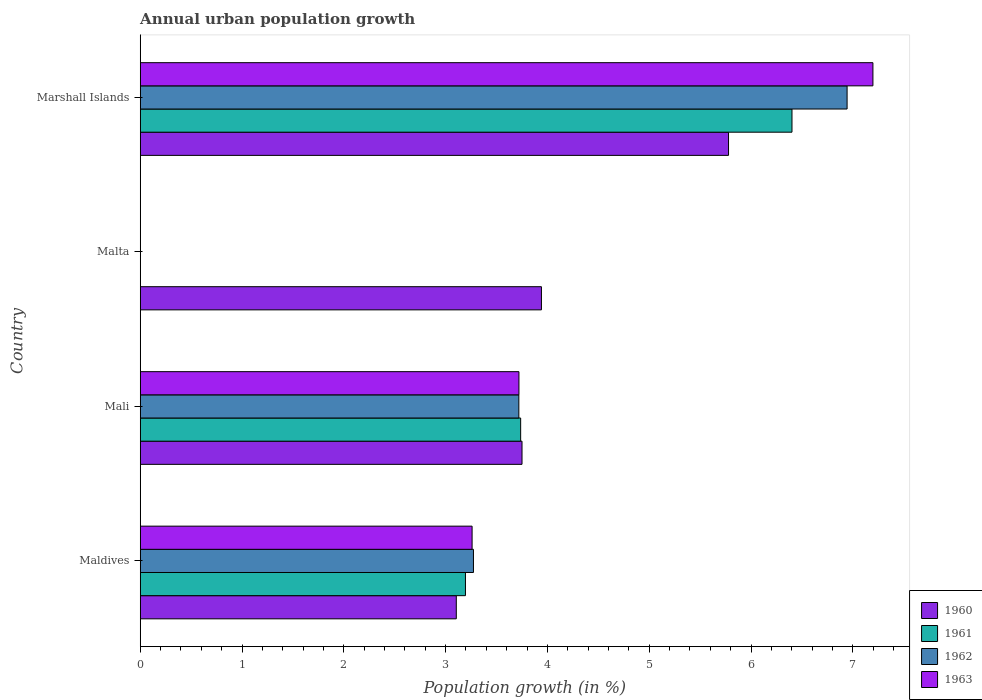How many bars are there on the 4th tick from the bottom?
Provide a short and direct response. 4. What is the label of the 1st group of bars from the top?
Your response must be concise. Marshall Islands. Across all countries, what is the maximum percentage of urban population growth in 1961?
Offer a very short reply. 6.4. Across all countries, what is the minimum percentage of urban population growth in 1960?
Your response must be concise. 3.1. In which country was the percentage of urban population growth in 1963 maximum?
Offer a very short reply. Marshall Islands. What is the total percentage of urban population growth in 1961 in the graph?
Provide a short and direct response. 13.33. What is the difference between the percentage of urban population growth in 1961 in Mali and that in Marshall Islands?
Offer a very short reply. -2.67. What is the difference between the percentage of urban population growth in 1961 in Maldives and the percentage of urban population growth in 1962 in Malta?
Offer a terse response. 3.19. What is the average percentage of urban population growth in 1963 per country?
Ensure brevity in your answer.  3.54. What is the difference between the percentage of urban population growth in 1961 and percentage of urban population growth in 1963 in Marshall Islands?
Provide a succinct answer. -0.8. What is the ratio of the percentage of urban population growth in 1963 in Mali to that in Marshall Islands?
Offer a terse response. 0.52. What is the difference between the highest and the second highest percentage of urban population growth in 1962?
Offer a terse response. 3.22. What is the difference between the highest and the lowest percentage of urban population growth in 1960?
Ensure brevity in your answer.  2.67. Is it the case that in every country, the sum of the percentage of urban population growth in 1963 and percentage of urban population growth in 1962 is greater than the percentage of urban population growth in 1960?
Offer a terse response. No. Are all the bars in the graph horizontal?
Your answer should be compact. Yes. Does the graph contain grids?
Offer a terse response. No. Where does the legend appear in the graph?
Your response must be concise. Bottom right. How many legend labels are there?
Keep it short and to the point. 4. How are the legend labels stacked?
Your response must be concise. Vertical. What is the title of the graph?
Make the answer very short. Annual urban population growth. Does "2006" appear as one of the legend labels in the graph?
Offer a very short reply. No. What is the label or title of the X-axis?
Ensure brevity in your answer.  Population growth (in %). What is the label or title of the Y-axis?
Your response must be concise. Country. What is the Population growth (in %) in 1960 in Maldives?
Offer a very short reply. 3.1. What is the Population growth (in %) in 1961 in Maldives?
Make the answer very short. 3.19. What is the Population growth (in %) of 1962 in Maldives?
Your answer should be very brief. 3.27. What is the Population growth (in %) in 1963 in Maldives?
Offer a very short reply. 3.26. What is the Population growth (in %) of 1960 in Mali?
Make the answer very short. 3.75. What is the Population growth (in %) of 1961 in Mali?
Keep it short and to the point. 3.74. What is the Population growth (in %) of 1962 in Mali?
Offer a very short reply. 3.72. What is the Population growth (in %) of 1963 in Mali?
Your response must be concise. 3.72. What is the Population growth (in %) of 1960 in Malta?
Your response must be concise. 3.94. What is the Population growth (in %) in 1961 in Malta?
Make the answer very short. 0. What is the Population growth (in %) in 1962 in Malta?
Provide a short and direct response. 0. What is the Population growth (in %) in 1960 in Marshall Islands?
Ensure brevity in your answer.  5.78. What is the Population growth (in %) of 1961 in Marshall Islands?
Offer a very short reply. 6.4. What is the Population growth (in %) in 1962 in Marshall Islands?
Offer a very short reply. 6.94. What is the Population growth (in %) in 1963 in Marshall Islands?
Your answer should be compact. 7.2. Across all countries, what is the maximum Population growth (in %) of 1960?
Provide a short and direct response. 5.78. Across all countries, what is the maximum Population growth (in %) of 1961?
Ensure brevity in your answer.  6.4. Across all countries, what is the maximum Population growth (in %) in 1962?
Provide a succinct answer. 6.94. Across all countries, what is the maximum Population growth (in %) in 1963?
Offer a very short reply. 7.2. Across all countries, what is the minimum Population growth (in %) of 1960?
Keep it short and to the point. 3.1. Across all countries, what is the minimum Population growth (in %) in 1961?
Ensure brevity in your answer.  0. Across all countries, what is the minimum Population growth (in %) in 1963?
Make the answer very short. 0. What is the total Population growth (in %) of 1960 in the graph?
Offer a very short reply. 16.58. What is the total Population growth (in %) of 1961 in the graph?
Your answer should be very brief. 13.33. What is the total Population growth (in %) of 1962 in the graph?
Your answer should be very brief. 13.94. What is the total Population growth (in %) of 1963 in the graph?
Make the answer very short. 14.18. What is the difference between the Population growth (in %) of 1960 in Maldives and that in Mali?
Provide a short and direct response. -0.65. What is the difference between the Population growth (in %) of 1961 in Maldives and that in Mali?
Provide a short and direct response. -0.54. What is the difference between the Population growth (in %) of 1962 in Maldives and that in Mali?
Offer a very short reply. -0.45. What is the difference between the Population growth (in %) of 1963 in Maldives and that in Mali?
Ensure brevity in your answer.  -0.46. What is the difference between the Population growth (in %) in 1960 in Maldives and that in Malta?
Make the answer very short. -0.84. What is the difference between the Population growth (in %) in 1960 in Maldives and that in Marshall Islands?
Provide a succinct answer. -2.67. What is the difference between the Population growth (in %) in 1961 in Maldives and that in Marshall Islands?
Your answer should be very brief. -3.21. What is the difference between the Population growth (in %) of 1962 in Maldives and that in Marshall Islands?
Offer a terse response. -3.67. What is the difference between the Population growth (in %) in 1963 in Maldives and that in Marshall Islands?
Keep it short and to the point. -3.94. What is the difference between the Population growth (in %) of 1960 in Mali and that in Malta?
Provide a short and direct response. -0.19. What is the difference between the Population growth (in %) in 1960 in Mali and that in Marshall Islands?
Provide a succinct answer. -2.03. What is the difference between the Population growth (in %) of 1961 in Mali and that in Marshall Islands?
Make the answer very short. -2.67. What is the difference between the Population growth (in %) in 1962 in Mali and that in Marshall Islands?
Offer a terse response. -3.22. What is the difference between the Population growth (in %) in 1963 in Mali and that in Marshall Islands?
Offer a very short reply. -3.48. What is the difference between the Population growth (in %) of 1960 in Malta and that in Marshall Islands?
Your answer should be compact. -1.84. What is the difference between the Population growth (in %) of 1960 in Maldives and the Population growth (in %) of 1961 in Mali?
Offer a terse response. -0.63. What is the difference between the Population growth (in %) in 1960 in Maldives and the Population growth (in %) in 1962 in Mali?
Provide a succinct answer. -0.61. What is the difference between the Population growth (in %) in 1960 in Maldives and the Population growth (in %) in 1963 in Mali?
Keep it short and to the point. -0.62. What is the difference between the Population growth (in %) of 1961 in Maldives and the Population growth (in %) of 1962 in Mali?
Keep it short and to the point. -0.52. What is the difference between the Population growth (in %) in 1961 in Maldives and the Population growth (in %) in 1963 in Mali?
Offer a very short reply. -0.53. What is the difference between the Population growth (in %) in 1962 in Maldives and the Population growth (in %) in 1963 in Mali?
Keep it short and to the point. -0.45. What is the difference between the Population growth (in %) in 1960 in Maldives and the Population growth (in %) in 1961 in Marshall Islands?
Ensure brevity in your answer.  -3.3. What is the difference between the Population growth (in %) in 1960 in Maldives and the Population growth (in %) in 1962 in Marshall Islands?
Give a very brief answer. -3.84. What is the difference between the Population growth (in %) of 1960 in Maldives and the Population growth (in %) of 1963 in Marshall Islands?
Provide a short and direct response. -4.09. What is the difference between the Population growth (in %) in 1961 in Maldives and the Population growth (in %) in 1962 in Marshall Islands?
Your answer should be very brief. -3.75. What is the difference between the Population growth (in %) of 1961 in Maldives and the Population growth (in %) of 1963 in Marshall Islands?
Provide a succinct answer. -4. What is the difference between the Population growth (in %) in 1962 in Maldives and the Population growth (in %) in 1963 in Marshall Islands?
Provide a short and direct response. -3.92. What is the difference between the Population growth (in %) in 1960 in Mali and the Population growth (in %) in 1961 in Marshall Islands?
Your answer should be very brief. -2.65. What is the difference between the Population growth (in %) in 1960 in Mali and the Population growth (in %) in 1962 in Marshall Islands?
Offer a very short reply. -3.19. What is the difference between the Population growth (in %) of 1960 in Mali and the Population growth (in %) of 1963 in Marshall Islands?
Provide a succinct answer. -3.45. What is the difference between the Population growth (in %) of 1961 in Mali and the Population growth (in %) of 1962 in Marshall Islands?
Keep it short and to the point. -3.21. What is the difference between the Population growth (in %) in 1961 in Mali and the Population growth (in %) in 1963 in Marshall Islands?
Provide a short and direct response. -3.46. What is the difference between the Population growth (in %) in 1962 in Mali and the Population growth (in %) in 1963 in Marshall Islands?
Your answer should be compact. -3.48. What is the difference between the Population growth (in %) of 1960 in Malta and the Population growth (in %) of 1961 in Marshall Islands?
Make the answer very short. -2.46. What is the difference between the Population growth (in %) of 1960 in Malta and the Population growth (in %) of 1962 in Marshall Islands?
Provide a succinct answer. -3. What is the difference between the Population growth (in %) in 1960 in Malta and the Population growth (in %) in 1963 in Marshall Islands?
Ensure brevity in your answer.  -3.26. What is the average Population growth (in %) of 1960 per country?
Offer a very short reply. 4.14. What is the average Population growth (in %) of 1961 per country?
Keep it short and to the point. 3.33. What is the average Population growth (in %) in 1962 per country?
Make the answer very short. 3.48. What is the average Population growth (in %) of 1963 per country?
Provide a succinct answer. 3.54. What is the difference between the Population growth (in %) in 1960 and Population growth (in %) in 1961 in Maldives?
Provide a succinct answer. -0.09. What is the difference between the Population growth (in %) of 1960 and Population growth (in %) of 1962 in Maldives?
Keep it short and to the point. -0.17. What is the difference between the Population growth (in %) in 1960 and Population growth (in %) in 1963 in Maldives?
Provide a short and direct response. -0.16. What is the difference between the Population growth (in %) in 1961 and Population growth (in %) in 1962 in Maldives?
Your response must be concise. -0.08. What is the difference between the Population growth (in %) in 1961 and Population growth (in %) in 1963 in Maldives?
Provide a succinct answer. -0.07. What is the difference between the Population growth (in %) of 1962 and Population growth (in %) of 1963 in Maldives?
Keep it short and to the point. 0.01. What is the difference between the Population growth (in %) of 1960 and Population growth (in %) of 1961 in Mali?
Your answer should be very brief. 0.01. What is the difference between the Population growth (in %) in 1960 and Population growth (in %) in 1962 in Mali?
Keep it short and to the point. 0.03. What is the difference between the Population growth (in %) in 1960 and Population growth (in %) in 1963 in Mali?
Make the answer very short. 0.03. What is the difference between the Population growth (in %) in 1961 and Population growth (in %) in 1962 in Mali?
Offer a terse response. 0.02. What is the difference between the Population growth (in %) of 1961 and Population growth (in %) of 1963 in Mali?
Ensure brevity in your answer.  0.02. What is the difference between the Population growth (in %) in 1962 and Population growth (in %) in 1963 in Mali?
Your answer should be compact. -0. What is the difference between the Population growth (in %) of 1960 and Population growth (in %) of 1961 in Marshall Islands?
Offer a terse response. -0.62. What is the difference between the Population growth (in %) of 1960 and Population growth (in %) of 1962 in Marshall Islands?
Make the answer very short. -1.16. What is the difference between the Population growth (in %) in 1960 and Population growth (in %) in 1963 in Marshall Islands?
Offer a terse response. -1.42. What is the difference between the Population growth (in %) in 1961 and Population growth (in %) in 1962 in Marshall Islands?
Your answer should be very brief. -0.54. What is the difference between the Population growth (in %) in 1961 and Population growth (in %) in 1963 in Marshall Islands?
Your response must be concise. -0.8. What is the difference between the Population growth (in %) of 1962 and Population growth (in %) of 1963 in Marshall Islands?
Your answer should be compact. -0.25. What is the ratio of the Population growth (in %) of 1960 in Maldives to that in Mali?
Provide a succinct answer. 0.83. What is the ratio of the Population growth (in %) of 1961 in Maldives to that in Mali?
Provide a short and direct response. 0.85. What is the ratio of the Population growth (in %) of 1962 in Maldives to that in Mali?
Provide a succinct answer. 0.88. What is the ratio of the Population growth (in %) of 1963 in Maldives to that in Mali?
Your answer should be compact. 0.88. What is the ratio of the Population growth (in %) of 1960 in Maldives to that in Malta?
Your answer should be very brief. 0.79. What is the ratio of the Population growth (in %) of 1960 in Maldives to that in Marshall Islands?
Provide a short and direct response. 0.54. What is the ratio of the Population growth (in %) of 1961 in Maldives to that in Marshall Islands?
Ensure brevity in your answer.  0.5. What is the ratio of the Population growth (in %) in 1962 in Maldives to that in Marshall Islands?
Make the answer very short. 0.47. What is the ratio of the Population growth (in %) in 1963 in Maldives to that in Marshall Islands?
Provide a short and direct response. 0.45. What is the ratio of the Population growth (in %) in 1960 in Mali to that in Malta?
Provide a short and direct response. 0.95. What is the ratio of the Population growth (in %) of 1960 in Mali to that in Marshall Islands?
Your answer should be compact. 0.65. What is the ratio of the Population growth (in %) of 1961 in Mali to that in Marshall Islands?
Keep it short and to the point. 0.58. What is the ratio of the Population growth (in %) in 1962 in Mali to that in Marshall Islands?
Make the answer very short. 0.54. What is the ratio of the Population growth (in %) of 1963 in Mali to that in Marshall Islands?
Offer a very short reply. 0.52. What is the ratio of the Population growth (in %) in 1960 in Malta to that in Marshall Islands?
Make the answer very short. 0.68. What is the difference between the highest and the second highest Population growth (in %) of 1960?
Provide a short and direct response. 1.84. What is the difference between the highest and the second highest Population growth (in %) of 1961?
Your response must be concise. 2.67. What is the difference between the highest and the second highest Population growth (in %) of 1962?
Your answer should be compact. 3.22. What is the difference between the highest and the second highest Population growth (in %) in 1963?
Offer a very short reply. 3.48. What is the difference between the highest and the lowest Population growth (in %) of 1960?
Provide a succinct answer. 2.67. What is the difference between the highest and the lowest Population growth (in %) of 1961?
Your answer should be compact. 6.4. What is the difference between the highest and the lowest Population growth (in %) of 1962?
Your answer should be compact. 6.94. What is the difference between the highest and the lowest Population growth (in %) of 1963?
Provide a short and direct response. 7.2. 